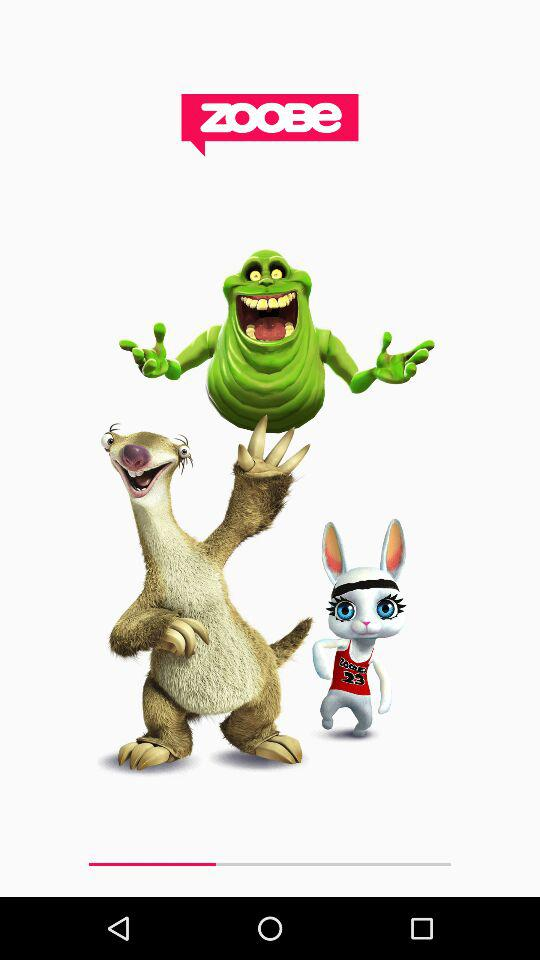What is the application name? The application name is "ZOOBe". 